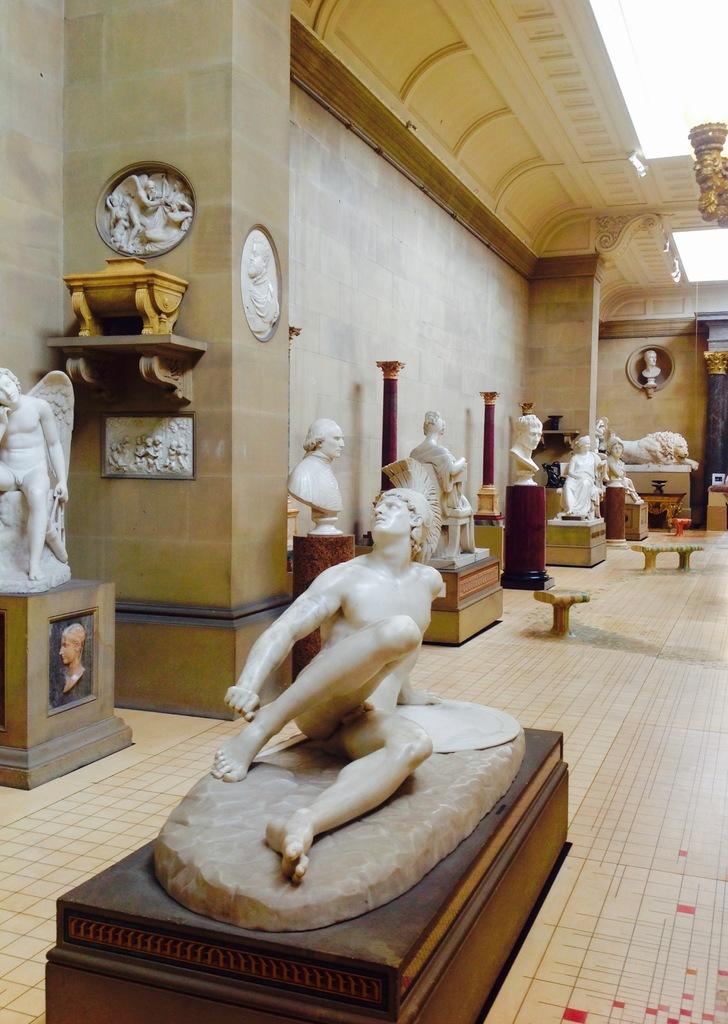What type of objects are in the middle of the image? There are statues of persons in the image. Where are the statues located in relation to other elements in the image? The statues are in the middle of the image. What is behind the statues in the image? The statues are in front of a wall. What type of quilt is draped over the statues in the image? There is no quilt present in the image; it features statues of persons in front of a wall. Can you see a train passing by in the image? There is no train visible in the image. 